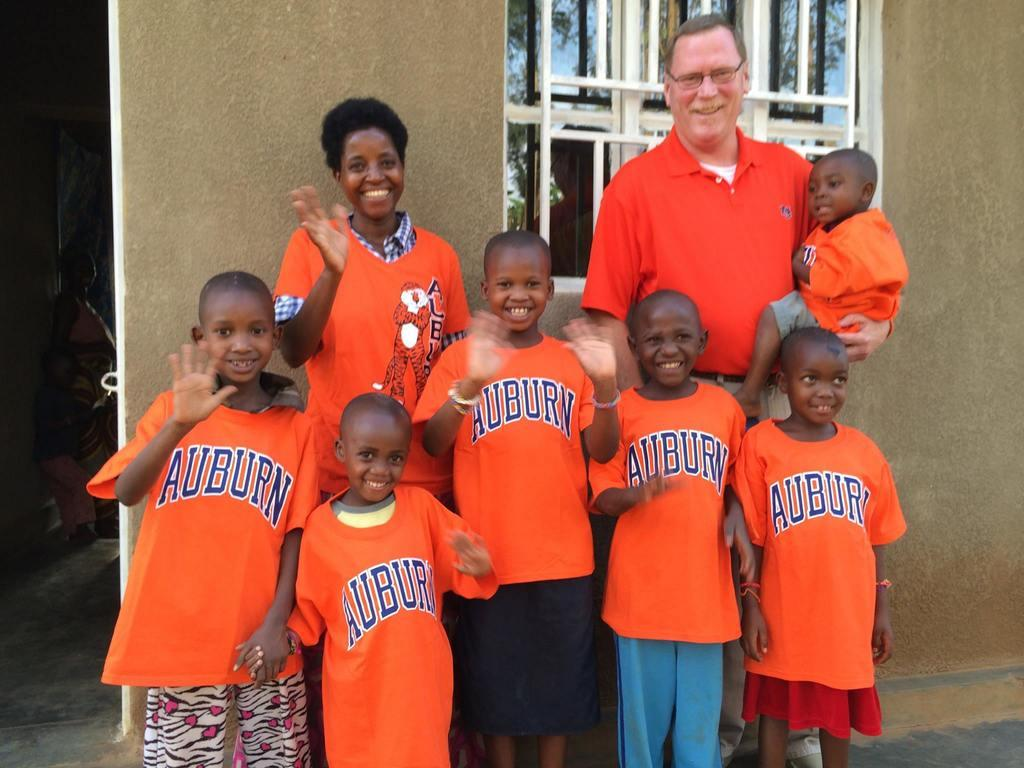<image>
Describe the image concisely. A group of children are wearing Auburn shirts and waving to the camera. 